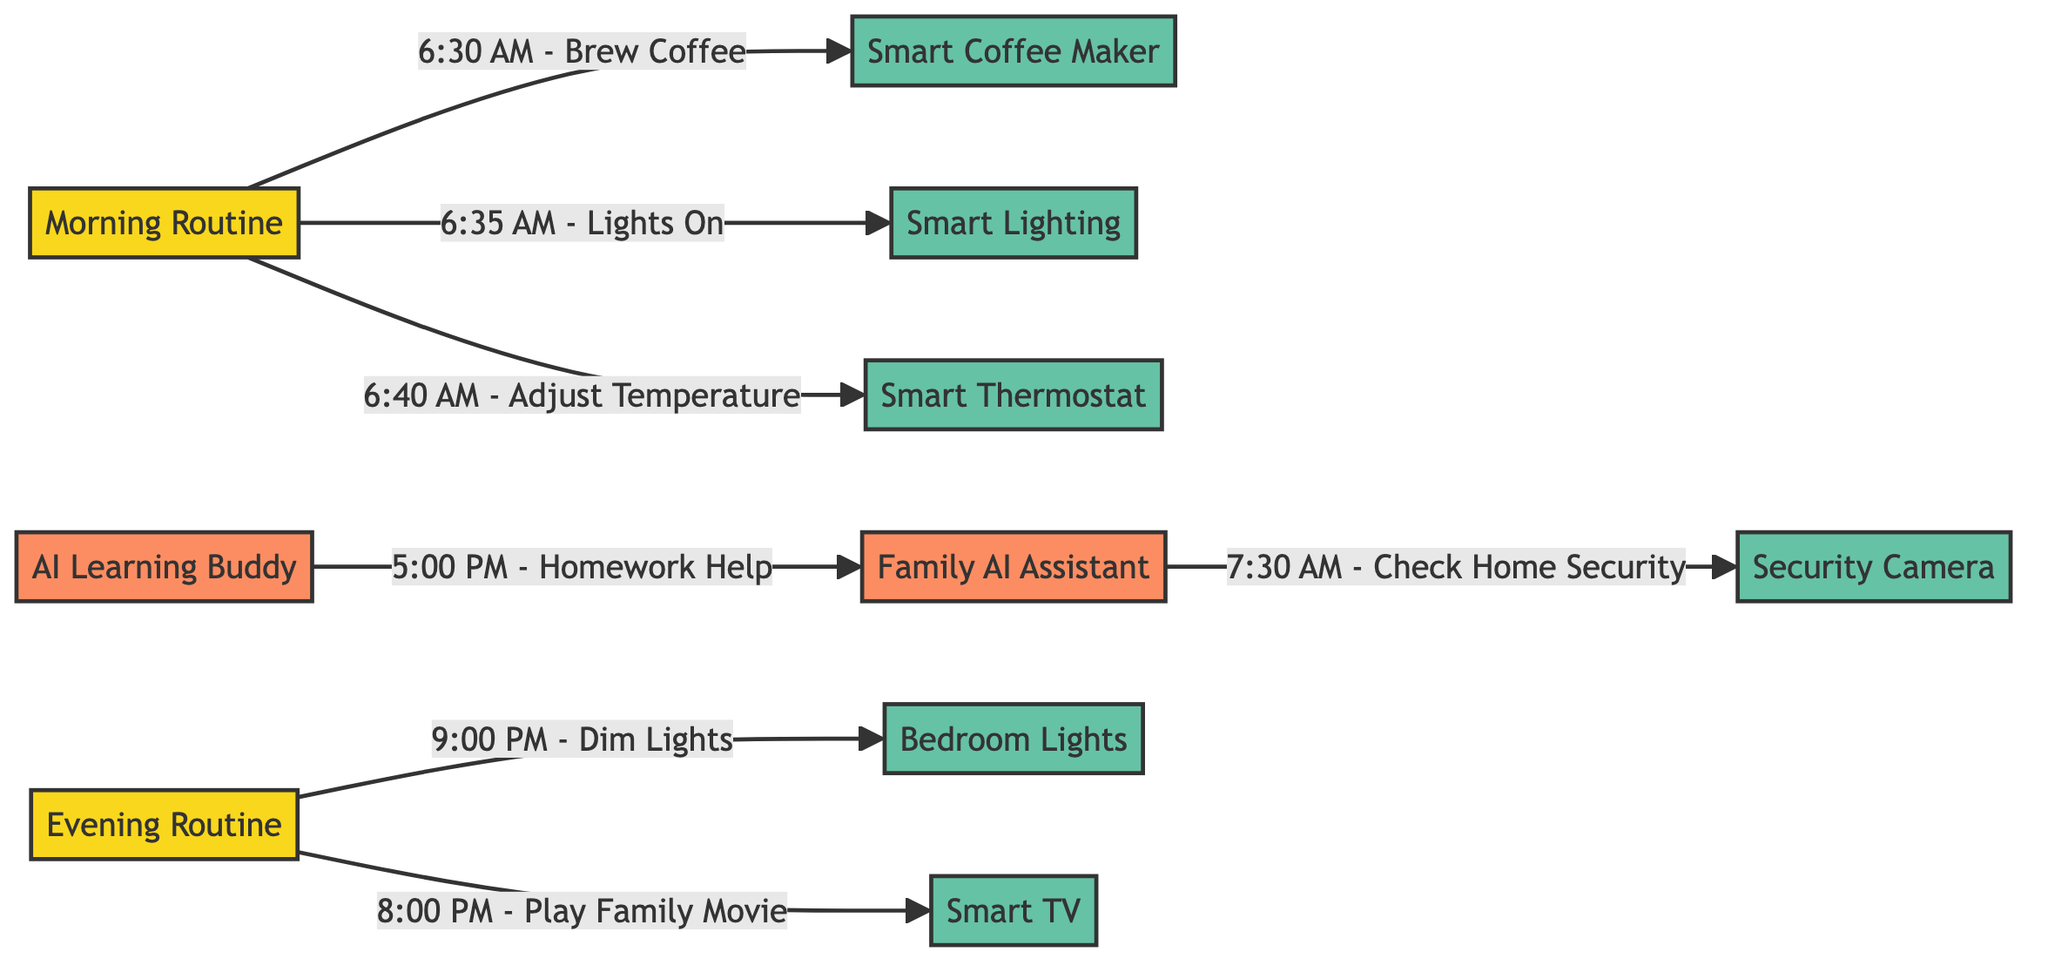How many smart devices are used in the morning routine? The morning routine includes three smart devices: the Smart Coffee Maker, Smart Lighting, and Smart Thermostat. These devices are directly linked to the morning routine node, indicating they are the only ones used during that time.
Answer: 3 What action is performed at 8:00 PM? At 8:00 PM, the action performed is to play a family movie, which is associated with the Smart TV node in the evening routine.
Answer: Play Family Movie Which AI-enabled device checks home security? The Family AI Assistant checks home security using the Security Camera device at 7:30 AM, which is explicitly stated in the flow that connects these two nodes.
Answer: Family AI Assistant What is the last action performed in the evening routine? The last action in the evening routine is to dim the lights at 9:00 PM, which clearly appears as a directed edge from the evening routine node to the Bedroom Lights device.
Answer: Dim Lights At what time does the Kindergarten Learning Buddy assist with homework? The AI Learning Buddy assists with homework at 5:00 PM, which is directly linked from the AI Learning Buddy node to the Family AI Assistant node.
Answer: 5:00 PM Which device is responsible for adjusting the temperature in the morning? The Smart Thermostat device is responsible for adjusting the temperature, as indicated in the diagram's morning routine flow at 6:40 AM.
Answer: Smart Thermostat How many nodes represent smart devices in the diagram? The diagram lists six nodes that represent smart devices: Smart Coffee Maker, Smart Lighting, Smart Thermostat, Security Camera, Bedroom Lights, and Smart TV. Count each of these to find the total.
Answer: 6 What routine is associated with the Security Camera? The Security Camera is associated with the morning routine, as it is monitored by the Family AI Assistant at 7:30 AM in this context.
Answer: Morning Routine Which device is utilized for homework help? The device utilized for homework help is the Family AI Assistant, which is linked to the AI Learning Buddy node as part of the evening routine at 5:00 PM.
Answer: Family AI Assistant 